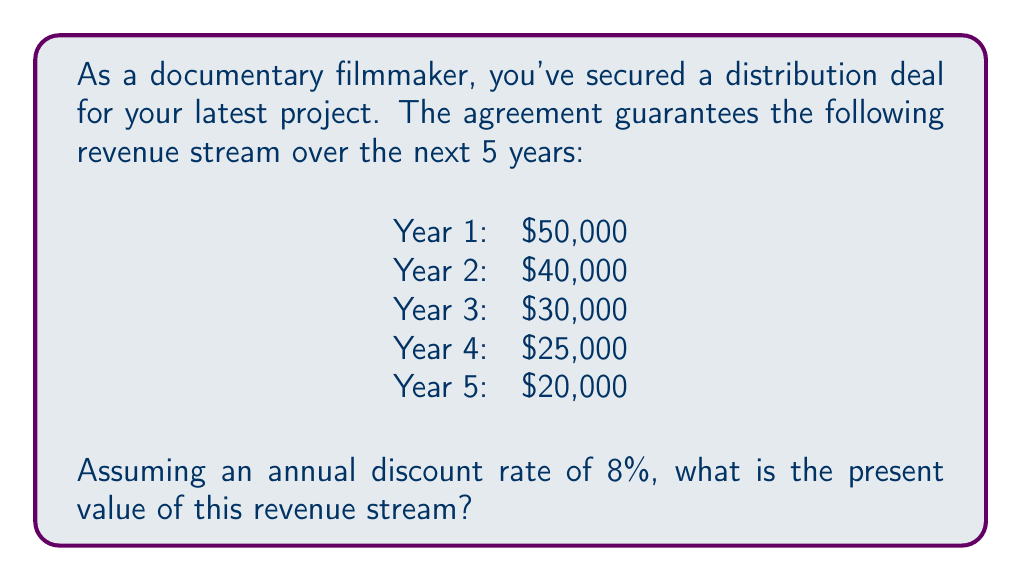Solve this math problem. To solve this problem, we need to calculate the present value of each year's revenue and then sum them up. We'll use the present value formula:

$$ PV = \frac{FV}{(1 + r)^n} $$

Where:
PV = Present Value
FV = Future Value
r = Discount rate
n = Number of years in the future

Let's calculate the present value for each year:

Year 1: $PV_1 = \frac{50,000}{(1 + 0.08)^1} = \frac{50,000}{1.08} = 46,296.30$

Year 2: $PV_2 = \frac{40,000}{(1 + 0.08)^2} = \frac{40,000}{1.1664} = 34,294.92$

Year 3: $PV_3 = \frac{30,000}{(1 + 0.08)^3} = \frac{30,000}{1.259712} = 23,815.22$

Year 4: $PV_4 = \frac{25,000}{(1 + 0.08)^4} = \frac{25,000}{1.36048896} = 18,375.86$

Year 5: $PV_5 = \frac{20,000}{(1 + 0.08)^5} = \frac{20,000}{1.469328077} = 13,611.74$

Now, we sum up all these present values:

$$ Total PV = PV_1 + PV_2 + PV_3 + PV_4 + PV_5 $$
$$ Total PV = 46,296.30 + 34,294.92 + 23,815.22 + 18,375.86 + 13,611.74 $$
$$ Total PV = 136,394.04 $$
Answer: The present value of the revenue stream is $136,394.04. 